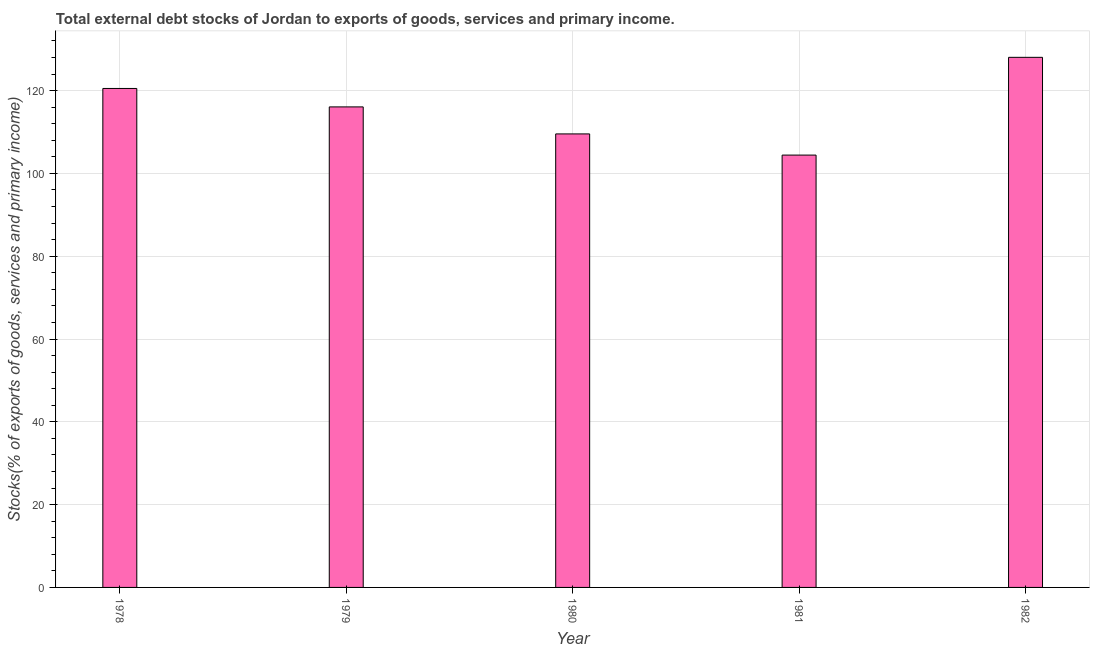What is the title of the graph?
Your response must be concise. Total external debt stocks of Jordan to exports of goods, services and primary income. What is the label or title of the X-axis?
Ensure brevity in your answer.  Year. What is the label or title of the Y-axis?
Ensure brevity in your answer.  Stocks(% of exports of goods, services and primary income). What is the external debt stocks in 1980?
Offer a terse response. 109.54. Across all years, what is the maximum external debt stocks?
Your answer should be compact. 128.04. Across all years, what is the minimum external debt stocks?
Keep it short and to the point. 104.43. In which year was the external debt stocks minimum?
Give a very brief answer. 1981. What is the sum of the external debt stocks?
Keep it short and to the point. 578.61. What is the difference between the external debt stocks in 1980 and 1981?
Provide a succinct answer. 5.11. What is the average external debt stocks per year?
Your response must be concise. 115.72. What is the median external debt stocks?
Keep it short and to the point. 116.07. In how many years, is the external debt stocks greater than 108 %?
Your response must be concise. 4. What is the ratio of the external debt stocks in 1981 to that in 1982?
Make the answer very short. 0.82. Is the external debt stocks in 1980 less than that in 1982?
Provide a succinct answer. Yes. What is the difference between the highest and the second highest external debt stocks?
Provide a succinct answer. 7.52. Is the sum of the external debt stocks in 1980 and 1981 greater than the maximum external debt stocks across all years?
Offer a terse response. Yes. What is the difference between the highest and the lowest external debt stocks?
Provide a succinct answer. 23.61. In how many years, is the external debt stocks greater than the average external debt stocks taken over all years?
Your answer should be compact. 3. Are all the bars in the graph horizontal?
Offer a terse response. No. What is the difference between two consecutive major ticks on the Y-axis?
Ensure brevity in your answer.  20. What is the Stocks(% of exports of goods, services and primary income) of 1978?
Ensure brevity in your answer.  120.53. What is the Stocks(% of exports of goods, services and primary income) in 1979?
Give a very brief answer. 116.07. What is the Stocks(% of exports of goods, services and primary income) in 1980?
Your response must be concise. 109.54. What is the Stocks(% of exports of goods, services and primary income) of 1981?
Provide a succinct answer. 104.43. What is the Stocks(% of exports of goods, services and primary income) of 1982?
Your response must be concise. 128.04. What is the difference between the Stocks(% of exports of goods, services and primary income) in 1978 and 1979?
Give a very brief answer. 4.46. What is the difference between the Stocks(% of exports of goods, services and primary income) in 1978 and 1980?
Your response must be concise. 10.98. What is the difference between the Stocks(% of exports of goods, services and primary income) in 1978 and 1981?
Offer a very short reply. 16.1. What is the difference between the Stocks(% of exports of goods, services and primary income) in 1978 and 1982?
Offer a very short reply. -7.52. What is the difference between the Stocks(% of exports of goods, services and primary income) in 1979 and 1980?
Your answer should be compact. 6.53. What is the difference between the Stocks(% of exports of goods, services and primary income) in 1979 and 1981?
Provide a short and direct response. 11.64. What is the difference between the Stocks(% of exports of goods, services and primary income) in 1979 and 1982?
Ensure brevity in your answer.  -11.97. What is the difference between the Stocks(% of exports of goods, services and primary income) in 1980 and 1981?
Offer a terse response. 5.11. What is the difference between the Stocks(% of exports of goods, services and primary income) in 1980 and 1982?
Keep it short and to the point. -18.5. What is the difference between the Stocks(% of exports of goods, services and primary income) in 1981 and 1982?
Offer a terse response. -23.61. What is the ratio of the Stocks(% of exports of goods, services and primary income) in 1978 to that in 1979?
Provide a succinct answer. 1.04. What is the ratio of the Stocks(% of exports of goods, services and primary income) in 1978 to that in 1981?
Make the answer very short. 1.15. What is the ratio of the Stocks(% of exports of goods, services and primary income) in 1978 to that in 1982?
Offer a terse response. 0.94. What is the ratio of the Stocks(% of exports of goods, services and primary income) in 1979 to that in 1980?
Your answer should be compact. 1.06. What is the ratio of the Stocks(% of exports of goods, services and primary income) in 1979 to that in 1981?
Your response must be concise. 1.11. What is the ratio of the Stocks(% of exports of goods, services and primary income) in 1979 to that in 1982?
Your answer should be very brief. 0.91. What is the ratio of the Stocks(% of exports of goods, services and primary income) in 1980 to that in 1981?
Offer a very short reply. 1.05. What is the ratio of the Stocks(% of exports of goods, services and primary income) in 1980 to that in 1982?
Your response must be concise. 0.86. What is the ratio of the Stocks(% of exports of goods, services and primary income) in 1981 to that in 1982?
Provide a succinct answer. 0.82. 